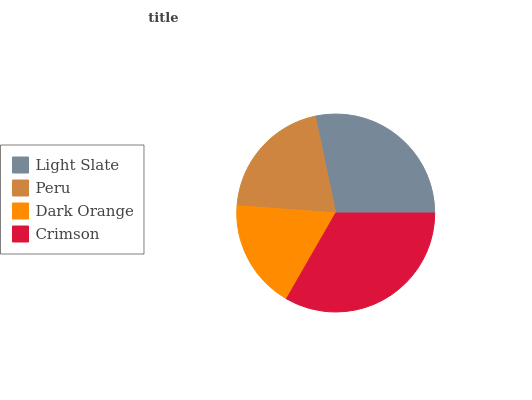Is Dark Orange the minimum?
Answer yes or no. Yes. Is Crimson the maximum?
Answer yes or no. Yes. Is Peru the minimum?
Answer yes or no. No. Is Peru the maximum?
Answer yes or no. No. Is Light Slate greater than Peru?
Answer yes or no. Yes. Is Peru less than Light Slate?
Answer yes or no. Yes. Is Peru greater than Light Slate?
Answer yes or no. No. Is Light Slate less than Peru?
Answer yes or no. No. Is Light Slate the high median?
Answer yes or no. Yes. Is Peru the low median?
Answer yes or no. Yes. Is Crimson the high median?
Answer yes or no. No. Is Light Slate the low median?
Answer yes or no. No. 